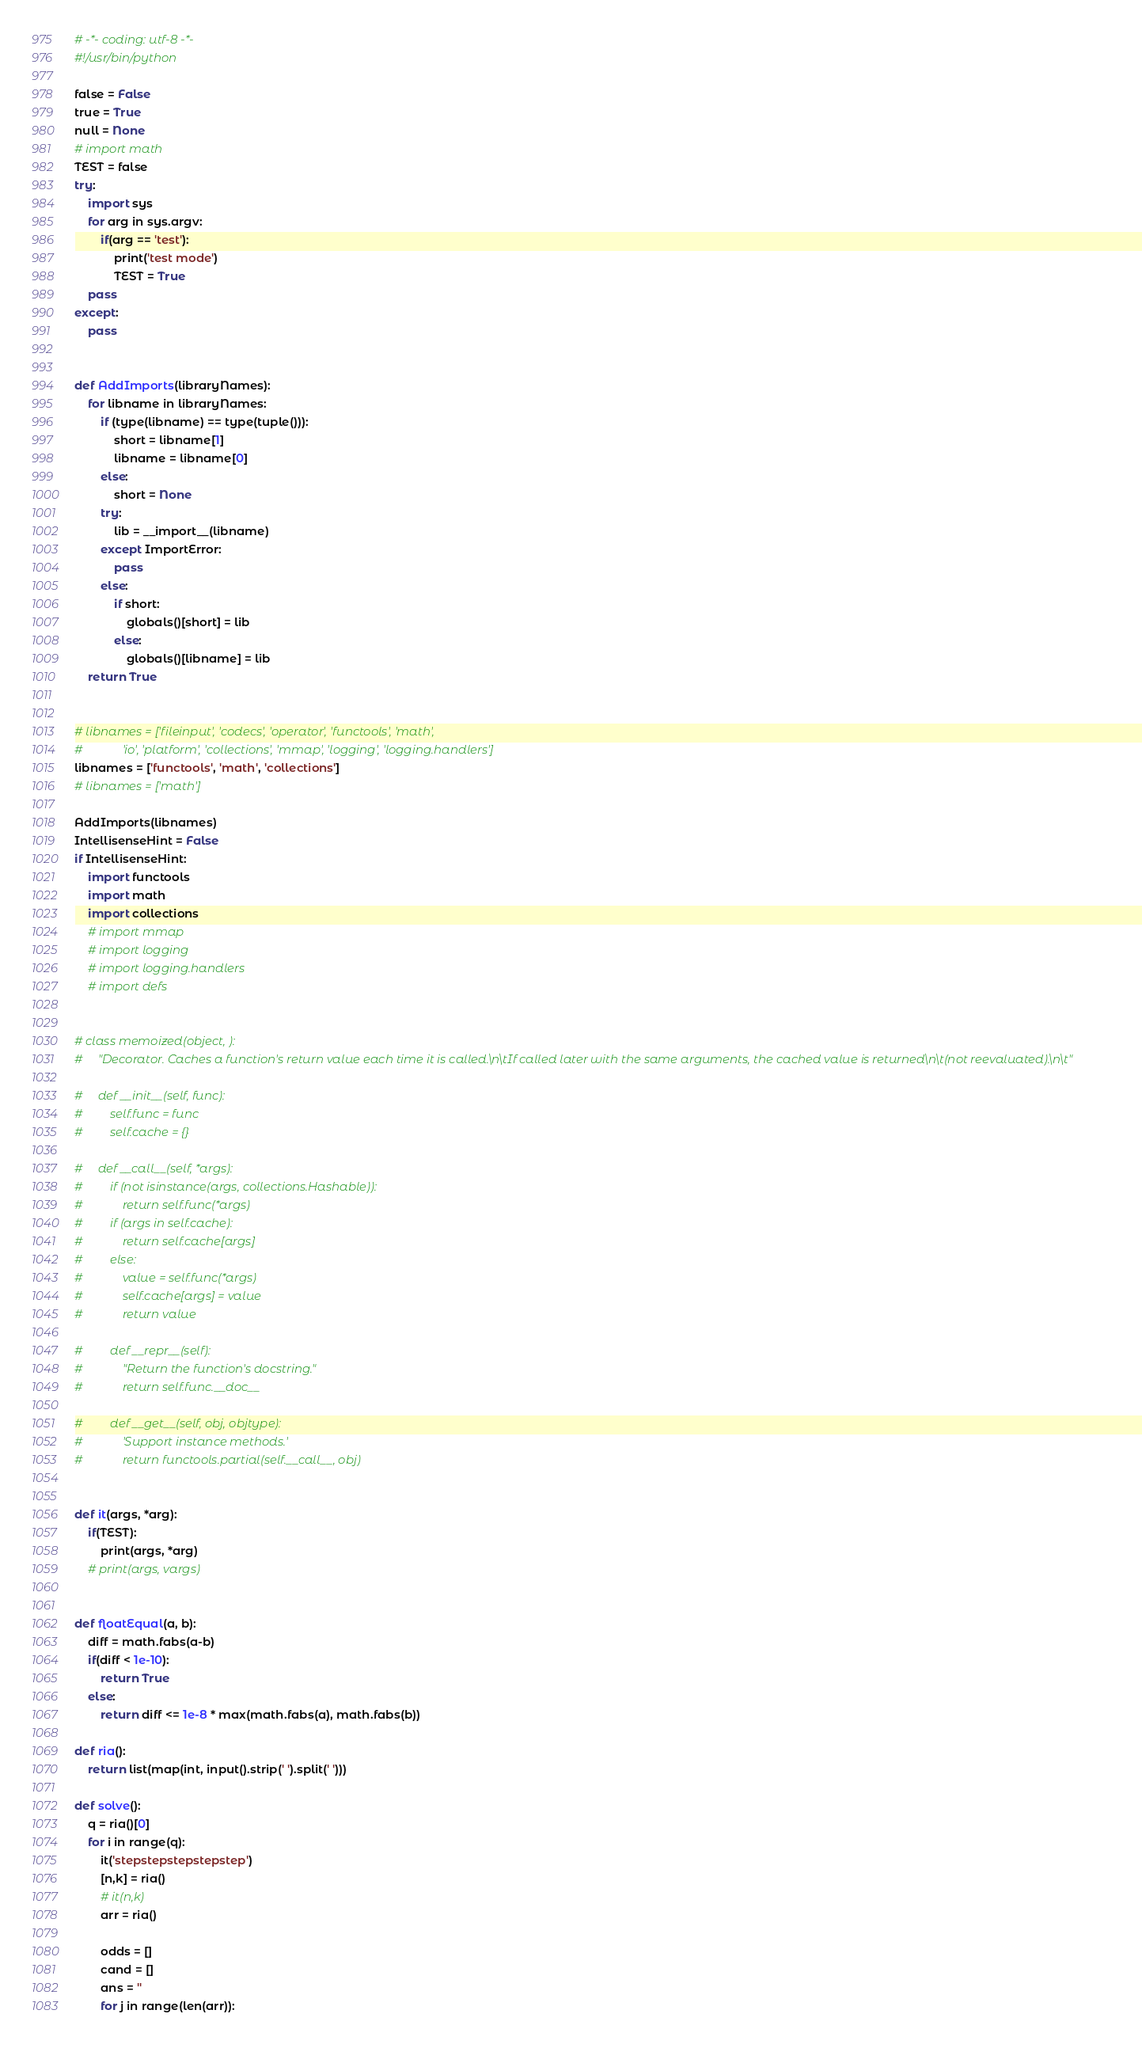Convert code to text. <code><loc_0><loc_0><loc_500><loc_500><_Python_># -*- coding: utf-8 -*-
#!/usr/bin/python

false = False
true = True
null = None
# import math
TEST = false
try:
    import sys
    for arg in sys.argv:
        if(arg == 'test'):
            print('test mode')
            TEST = True
    pass
except:
    pass


def AddImports(libraryNames):
    for libname in libraryNames:
        if (type(libname) == type(tuple())):
            short = libname[1]
            libname = libname[0]
        else:
            short = None
        try:
            lib = __import__(libname)
        except ImportError:
            pass
        else:
            if short:
                globals()[short] = lib
            else:
                globals()[libname] = lib
    return True


# libnames = ['fileinput', 'codecs', 'operator', 'functools', 'math',
#             'io', 'platform', 'collections', 'mmap', 'logging', 'logging.handlers']
libnames = ['functools', 'math', 'collections']
# libnames = ['math']

AddImports(libnames)
IntellisenseHint = False
if IntellisenseHint:
    import functools
    import math
    import collections
    # import mmap
    # import logging
    # import logging.handlers
    # import defs


# class memoized(object, ):
#     "Decorator. Caches a function's return value each time it is called.\n\tIf called later with the same arguments, the cached value is returned\n\t(not reevaluated).\n\t"

#     def __init__(self, func):
#         self.func = func
#         self.cache = {}

#     def __call__(self, *args):
#         if (not isinstance(args, collections.Hashable)):
#             return self.func(*args)
#         if (args in self.cache):
#             return self.cache[args]
#         else:
#             value = self.func(*args)
#             self.cache[args] = value
#             return value

#         def __repr__(self):
#             "Return the function's docstring."
#             return self.func.__doc__

#         def __get__(self, obj, objtype):
#             'Support instance methods.'
#             return functools.partial(self.__call__, obj)


def it(args, *arg):
    if(TEST):
        print(args, *arg)
    # print(args, vargs)


def floatEqual(a, b):
    diff = math.fabs(a-b)
    if(diff < 1e-10):
        return True
    else:
        return diff <= 1e-8 * max(math.fabs(a), math.fabs(b))

def ria():
    return list(map(int, input().strip(' ').split(' ')))

def solve():
    q = ria()[0]
    for i in range(q):
        it('stepstepstepstepstep')
        [n,k] = ria()
        # it(n,k)
        arr = ria()

        odds = []
        cand = []
        ans = ''
        for j in range(len(arr)):</code> 